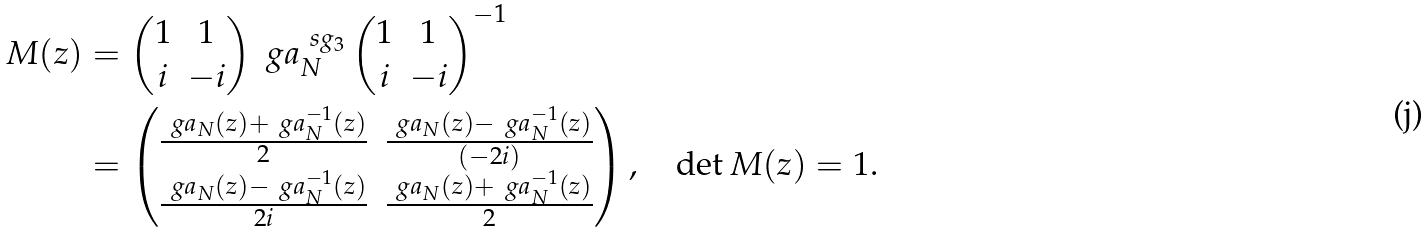Convert formula to latex. <formula><loc_0><loc_0><loc_500><loc_500>M ( z ) & = \begin{pmatrix} 1 & 1 \\ i & - i \end{pmatrix} \ g a _ { N } ^ { \ s g _ { 3 } } \begin{pmatrix} 1 & 1 \\ i & - i \end{pmatrix} ^ { - 1 } \\ & = \begin{pmatrix} \frac { \ g a _ { N } ( z ) + \ g a _ { N } ^ { - 1 } ( z ) } { 2 } & \frac { \ g a _ { N } ( z ) - \ g a _ { N } ^ { - 1 } ( z ) } { ( - 2 i ) } \\ \frac { \ g a _ { N } ( z ) - \ g a _ { N } ^ { - 1 } ( z ) } { 2 i } & \frac { \ g a _ { N } ( z ) + \ g a _ { N } ^ { - 1 } ( z ) } { 2 } \end{pmatrix} , \quad \det M ( z ) = 1 .</formula> 